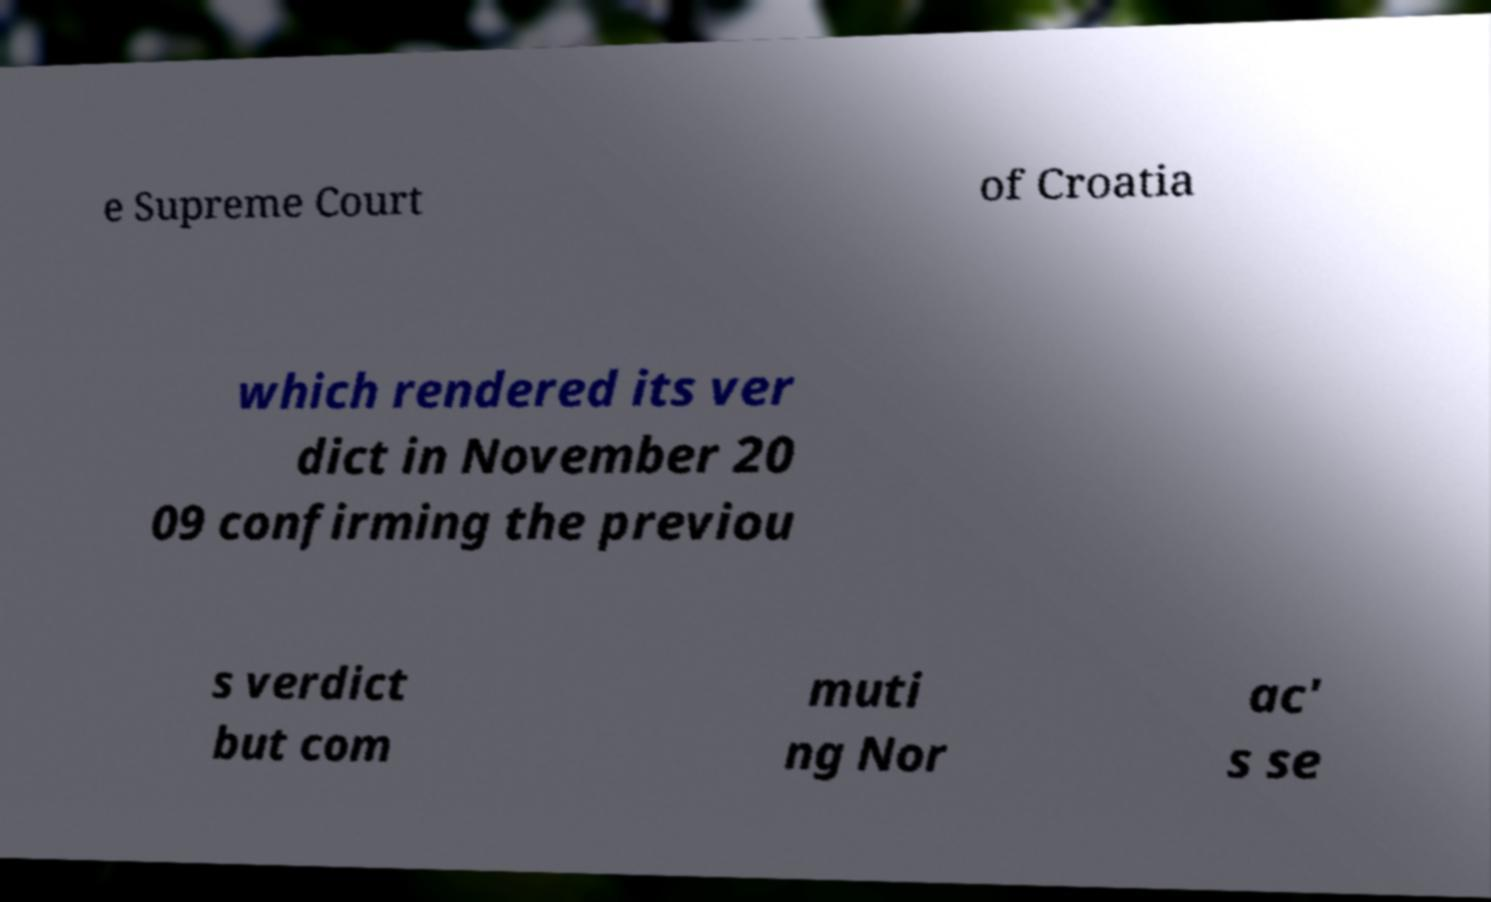For documentation purposes, I need the text within this image transcribed. Could you provide that? e Supreme Court of Croatia which rendered its ver dict in November 20 09 confirming the previou s verdict but com muti ng Nor ac' s se 